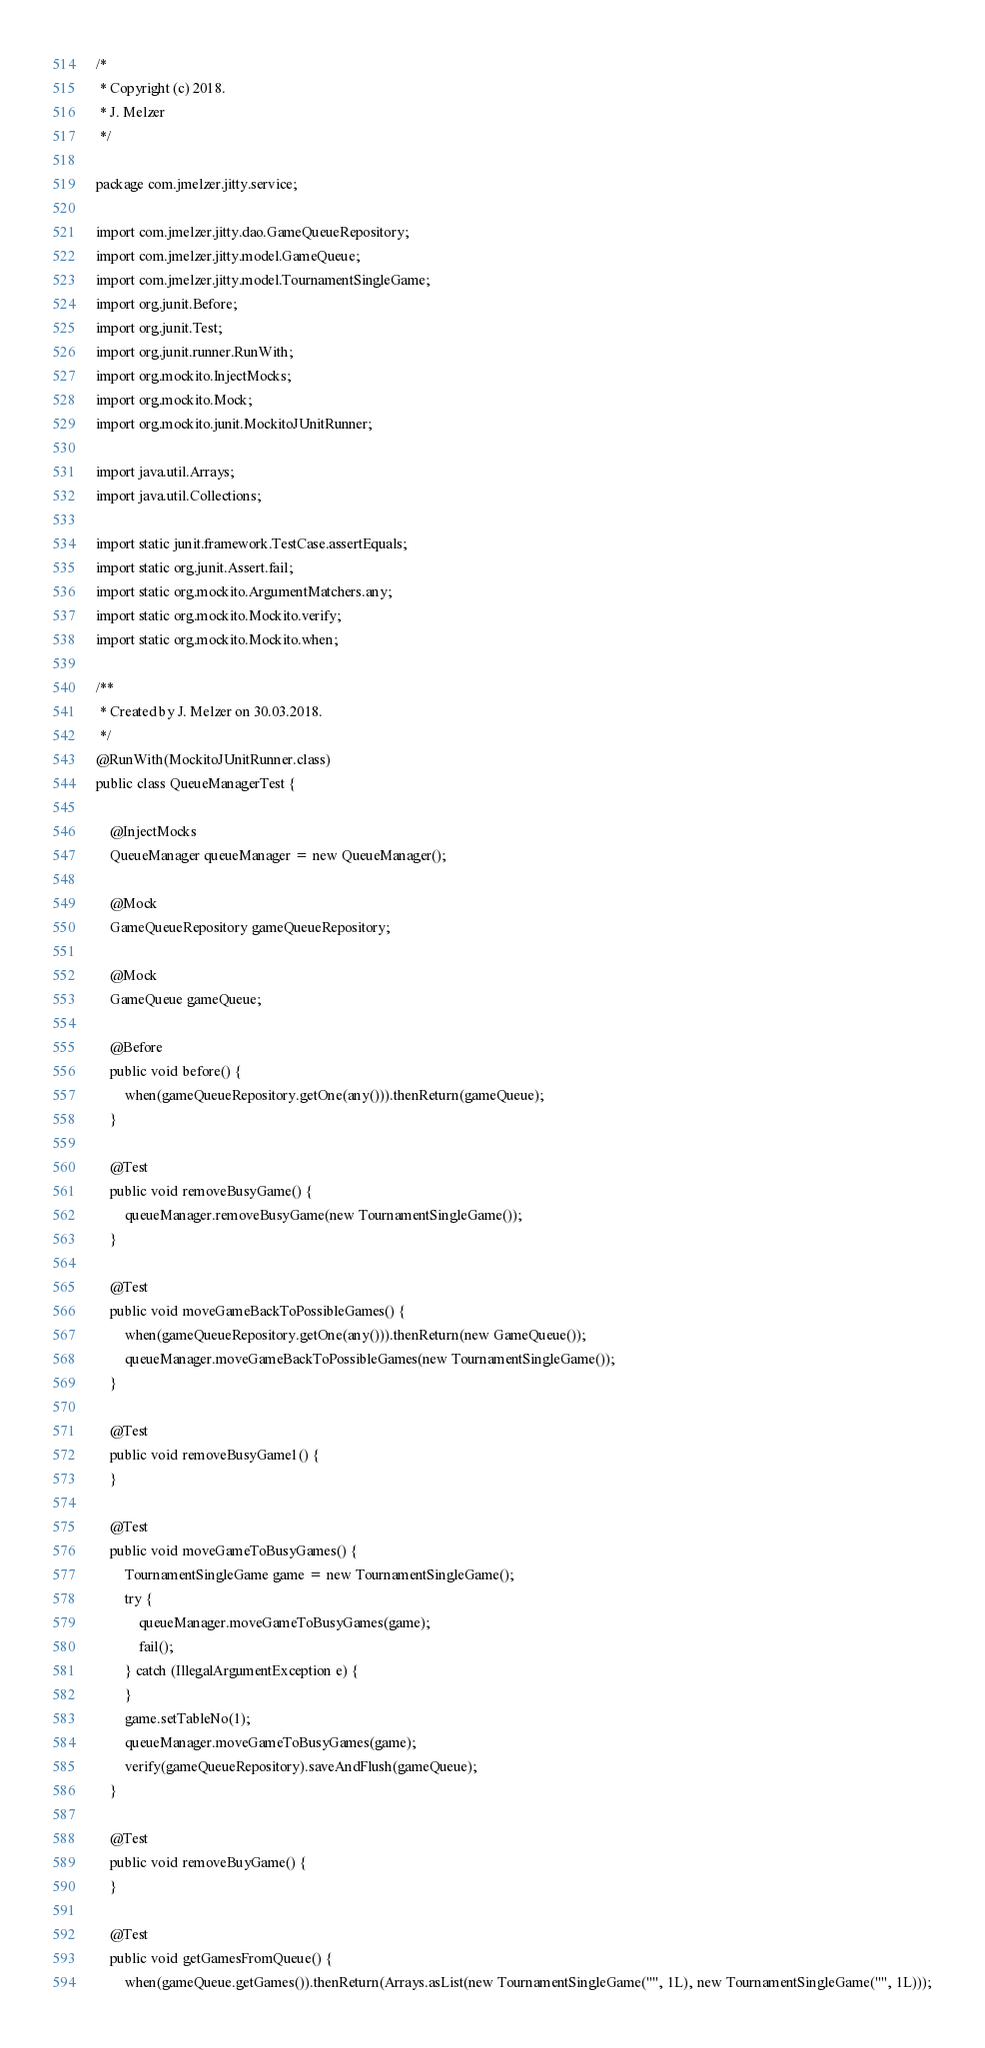<code> <loc_0><loc_0><loc_500><loc_500><_Java_>/*
 * Copyright (c) 2018.
 * J. Melzer
 */

package com.jmelzer.jitty.service;

import com.jmelzer.jitty.dao.GameQueueRepository;
import com.jmelzer.jitty.model.GameQueue;
import com.jmelzer.jitty.model.TournamentSingleGame;
import org.junit.Before;
import org.junit.Test;
import org.junit.runner.RunWith;
import org.mockito.InjectMocks;
import org.mockito.Mock;
import org.mockito.junit.MockitoJUnitRunner;

import java.util.Arrays;
import java.util.Collections;

import static junit.framework.TestCase.assertEquals;
import static org.junit.Assert.fail;
import static org.mockito.ArgumentMatchers.any;
import static org.mockito.Mockito.verify;
import static org.mockito.Mockito.when;

/**
 * Created by J. Melzer on 30.03.2018.
 */
@RunWith(MockitoJUnitRunner.class)
public class QueueManagerTest {

    @InjectMocks
    QueueManager queueManager = new QueueManager();

    @Mock
    GameQueueRepository gameQueueRepository;

    @Mock
    GameQueue gameQueue;

    @Before
    public void before() {
        when(gameQueueRepository.getOne(any())).thenReturn(gameQueue);
    }

    @Test
    public void removeBusyGame() {
        queueManager.removeBusyGame(new TournamentSingleGame());
    }

    @Test
    public void moveGameBackToPossibleGames() {
        when(gameQueueRepository.getOne(any())).thenReturn(new GameQueue());
        queueManager.moveGameBackToPossibleGames(new TournamentSingleGame());
    }

    @Test
    public void removeBusyGame1() {
    }

    @Test
    public void moveGameToBusyGames() {
        TournamentSingleGame game = new TournamentSingleGame();
        try {
            queueManager.moveGameToBusyGames(game);
            fail();
        } catch (IllegalArgumentException e) {
        }
        game.setTableNo(1);
        queueManager.moveGameToBusyGames(game);
        verify(gameQueueRepository).saveAndFlush(gameQueue);
    }

    @Test
    public void removeBuyGame() {
    }

    @Test
    public void getGamesFromQueue() {
        when(gameQueue.getGames()).thenReturn(Arrays.asList(new TournamentSingleGame("", 1L), new TournamentSingleGame("", 1L)));</code> 